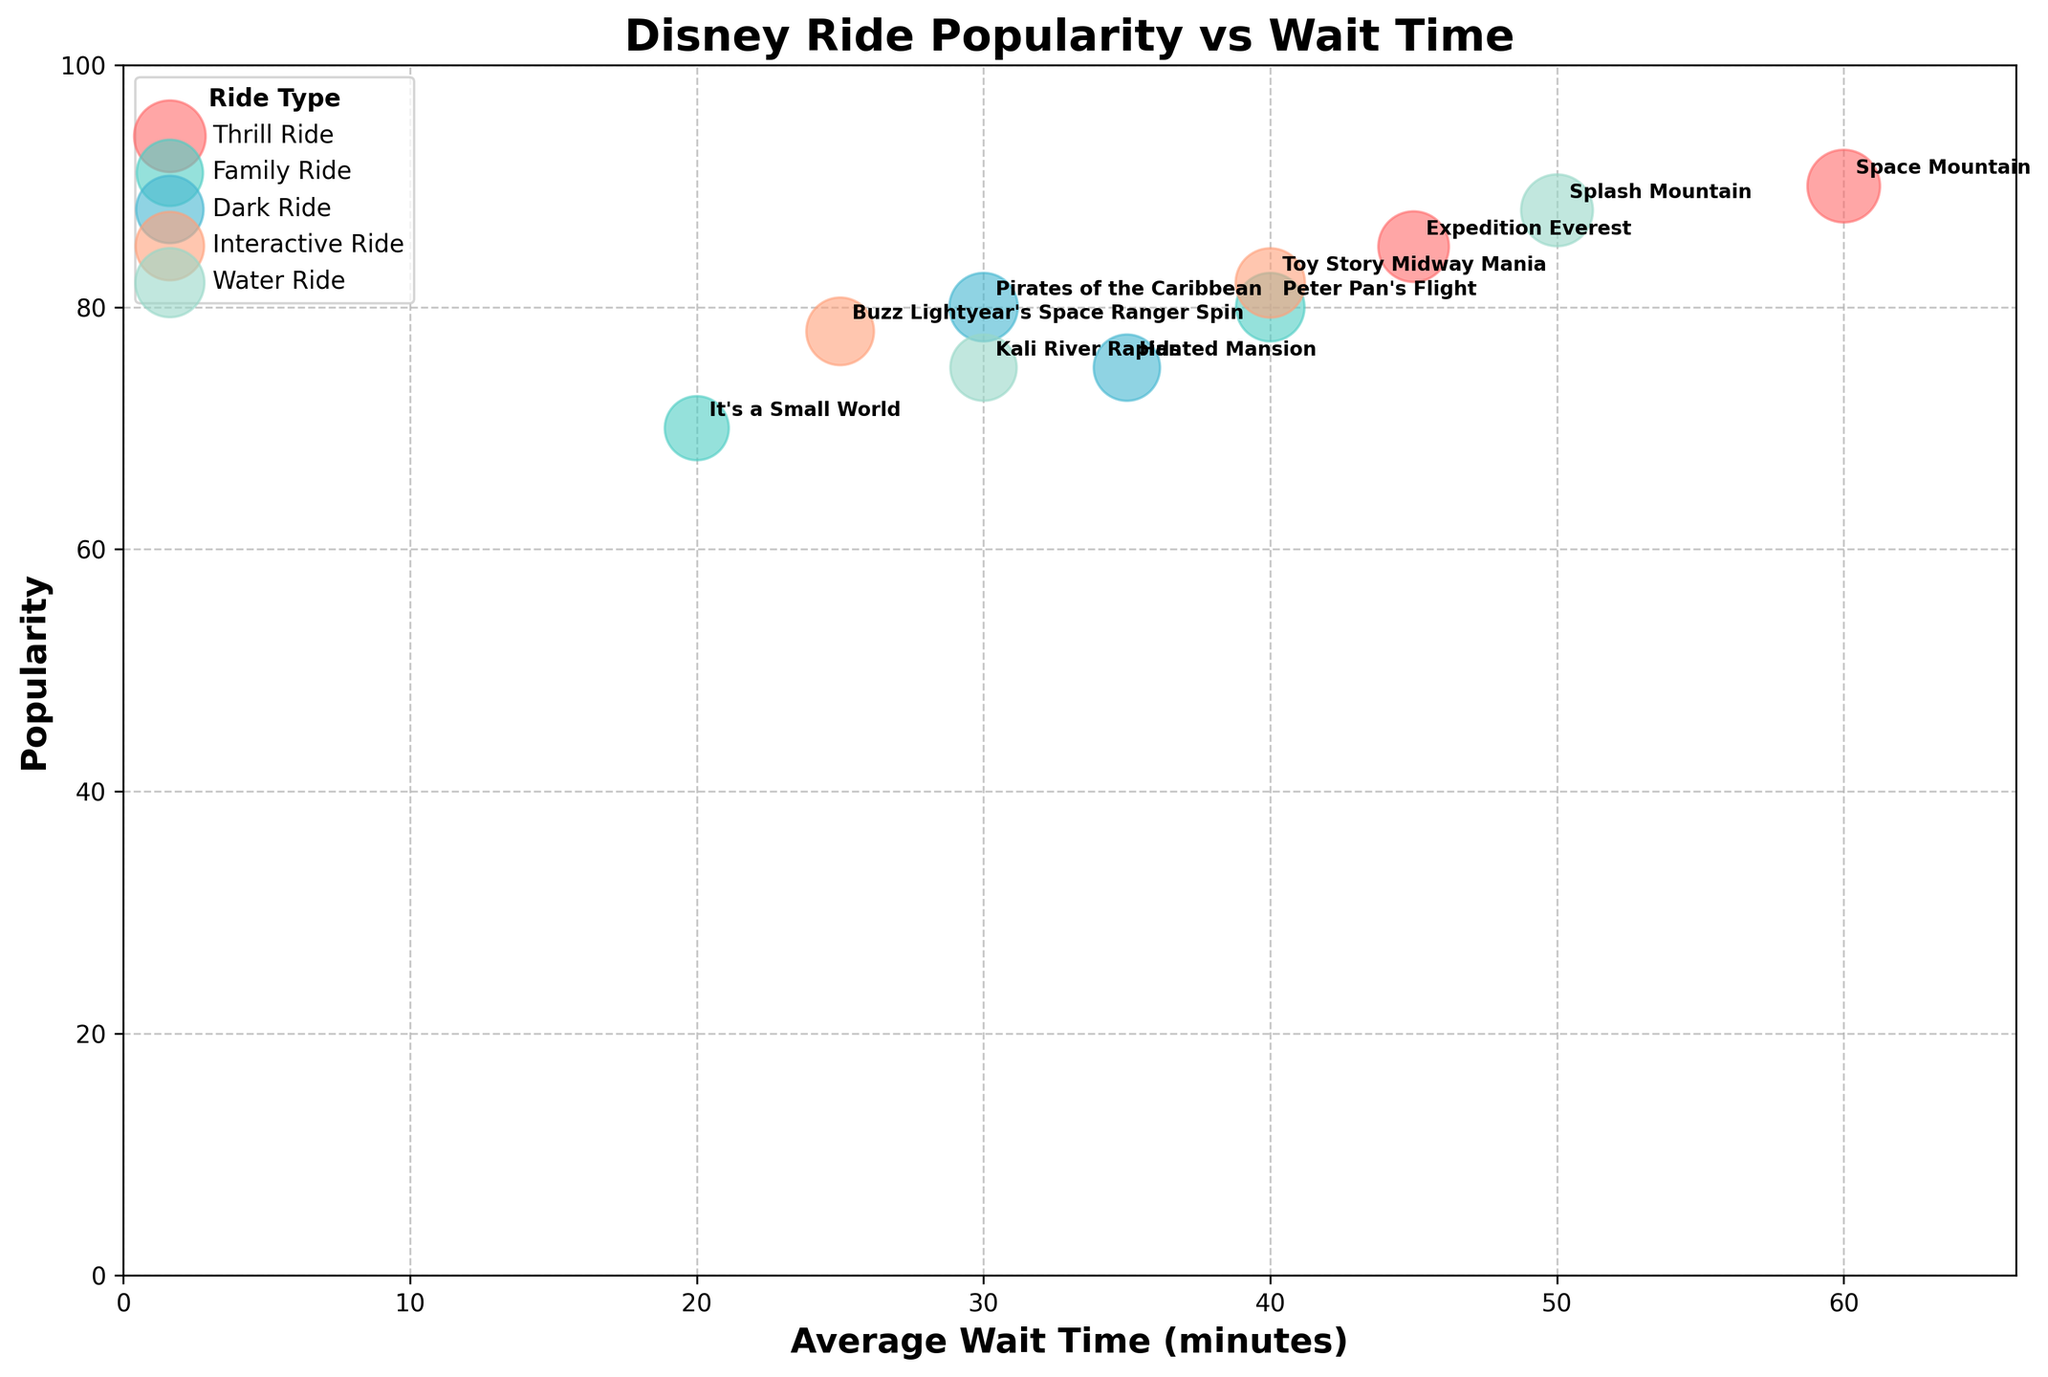Which ride has the highest average wait time? The ride with the highest average wait time is the one placed farthest to the right on the x-axis. Space Mountain is positioned at an average wait time of 60 minutes.
Answer: Space Mountain What is the average wait time for the Family Ride type? The Family Rides shown are Peter Pan's Flight and It's a Small World, with wait times of 40 and 20 minutes, respectively. The average is calculated as (40 + 20) / 2 = 30 minutes.
Answer: 30 minutes Which ride type has the highest popularity based on the largest bubble size? The Thrill Ride category has the largest bubbles, indicating the highest popularity. Space Mountain's bubble is the largest, suggesting it has the highest popularity score of 90.
Answer: Thrill Ride How many ride types are represented in the chart? By looking at the color legend on the chart, one can count the different ride types. These are Thrill Ride, Family Ride, Dark Ride, Interactive Ride, and Water Ride, making a total of 5.
Answer: 5 Which ride from the Dark Ride category has a lower average wait time? The Dark Rides are Haunted Mansion and Pirates of the Caribbean. Haunted Mansion has an average wait time of 35 minutes, and Pirates of the Caribbean has an average wait time of 30 minutes. Thus, Pirates of the Caribbean has the lower wait time.
Answer: Pirates of the Caribbean Is Splash Mountain more popular than Expedition Everest? By comparing the y-axis values (popularity), Splash Mountain has a popularity of 88, while Expedition Everest has a popularity of 85. Since 88 is greater than 85, Splash Mountain is more popular.
Answer: Yes How does Toy Story Midway Mania's average wait time compare to Buzz Lightyear's Space Ranger Spin? Toy Story Midway Mania has an average wait time of 40 minutes while Buzz Lightyear's Space Ranger Spin has 25 minutes. So, Toy Story Midway Mania has a longer wait time.
Answer: Toy Story Midway Mania has a longer wait time Which ride with an average wait time below 35 minutes has the highest popularity? The rides with average wait times below 35 minutes are It's a Small World, Haunted Mansion, Pirates of the Caribbean, Buzz Lightyear's Space Ranger Spin, and Kali River Rapids. Among these, Pirates of the Caribbean has the highest popularity at 80.
Answer: Pirates of the Caribbean What is the common age range for the rides in the Interactive Ride category? The Interactive Rides are Buzz Lightyear's Space Ranger Spin and Toy Story Midway Mania. They both list an age range of 6-14.
Answer: 6-14 